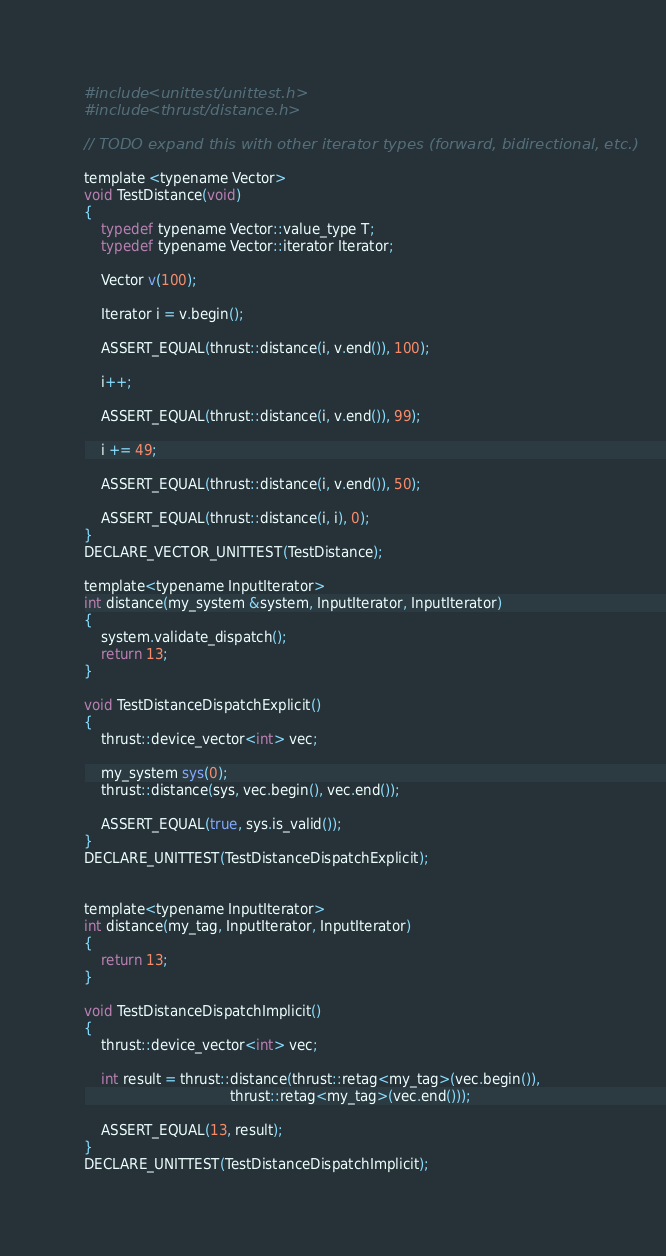<code> <loc_0><loc_0><loc_500><loc_500><_Cuda_>#include <unittest/unittest.h>
#include <thrust/distance.h>

// TODO expand this with other iterator types (forward, bidirectional, etc.)

template <typename Vector>
void TestDistance(void)
{
    typedef typename Vector::value_type T;
    typedef typename Vector::iterator Iterator;

    Vector v(100);

    Iterator i = v.begin();

    ASSERT_EQUAL(thrust::distance(i, v.end()), 100);

    i++;

    ASSERT_EQUAL(thrust::distance(i, v.end()), 99);

    i += 49;

    ASSERT_EQUAL(thrust::distance(i, v.end()), 50);
    
    ASSERT_EQUAL(thrust::distance(i, i), 0);
}
DECLARE_VECTOR_UNITTEST(TestDistance);

template<typename InputIterator>
int distance(my_system &system, InputIterator, InputIterator)
{
    system.validate_dispatch();
    return 13;
}

void TestDistanceDispatchExplicit()
{
    thrust::device_vector<int> vec;

    my_system sys(0);
    thrust::distance(sys, vec.begin(), vec.end());

    ASSERT_EQUAL(true, sys.is_valid());
}
DECLARE_UNITTEST(TestDistanceDispatchExplicit);


template<typename InputIterator>
int distance(my_tag, InputIterator, InputIterator)
{
    return 13;
}

void TestDistanceDispatchImplicit()
{
    thrust::device_vector<int> vec;

    int result = thrust::distance(thrust::retag<my_tag>(vec.begin()),
                                  thrust::retag<my_tag>(vec.end()));

    ASSERT_EQUAL(13, result);
}
DECLARE_UNITTEST(TestDistanceDispatchImplicit);

</code> 